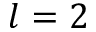<formula> <loc_0><loc_0><loc_500><loc_500>l = 2</formula> 